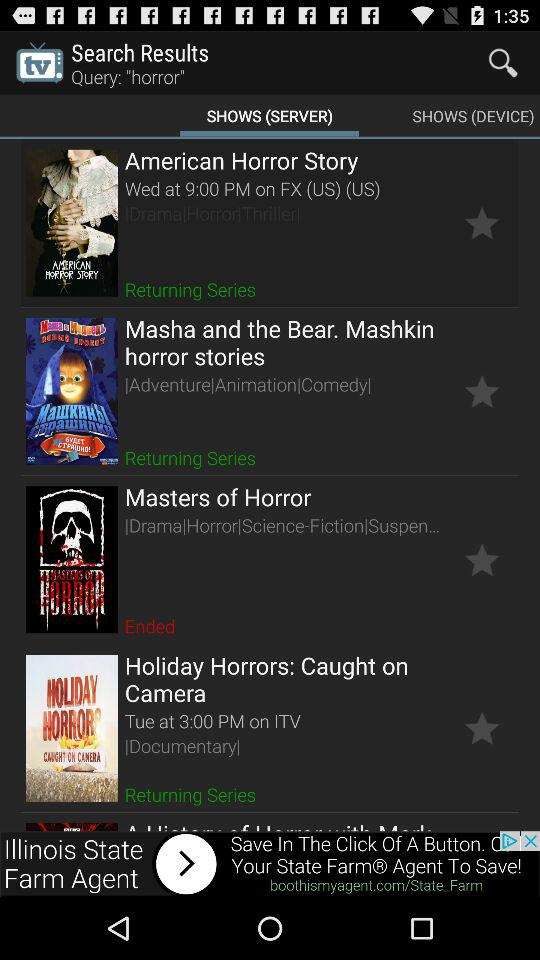What is the show timing of masters of horror?
When the provided information is insufficient, respond with <no answer>. <no answer> 